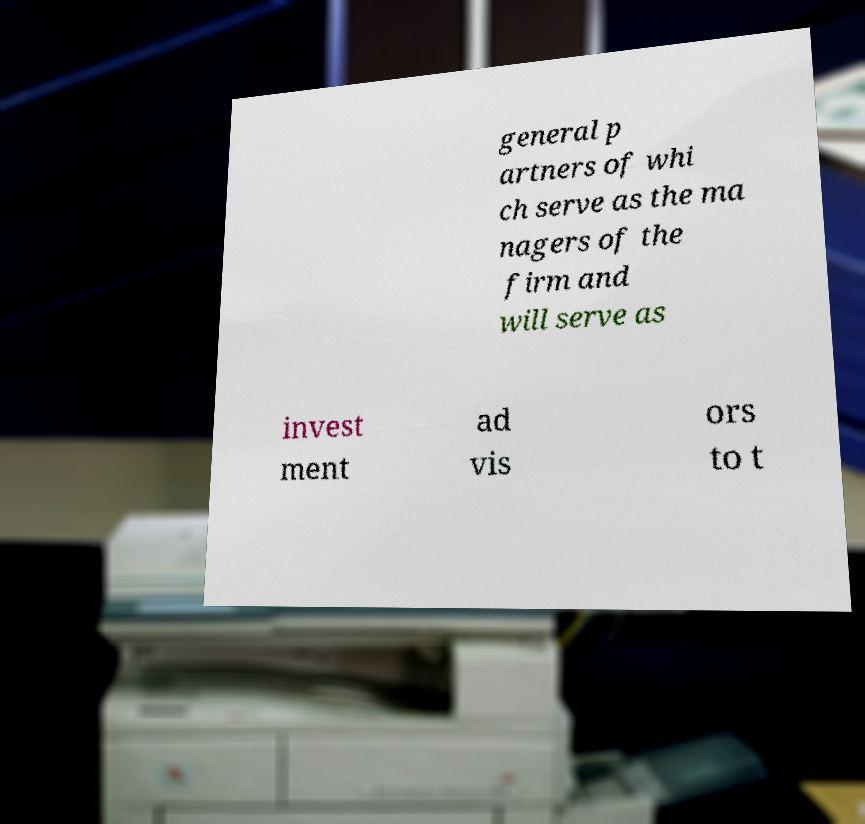I need the written content from this picture converted into text. Can you do that? general p artners of whi ch serve as the ma nagers of the firm and will serve as invest ment ad vis ors to t 